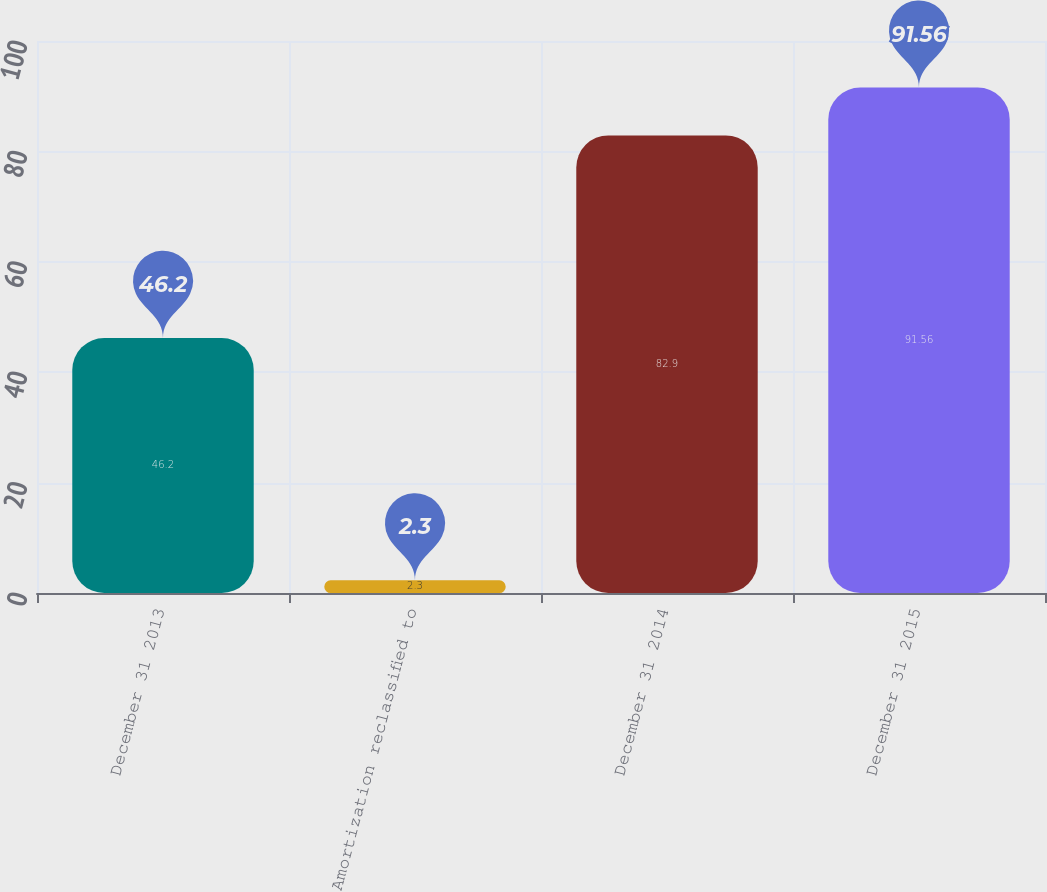<chart> <loc_0><loc_0><loc_500><loc_500><bar_chart><fcel>December 31 2013<fcel>Amortization reclassified to<fcel>December 31 2014<fcel>December 31 2015<nl><fcel>46.2<fcel>2.3<fcel>82.9<fcel>91.56<nl></chart> 